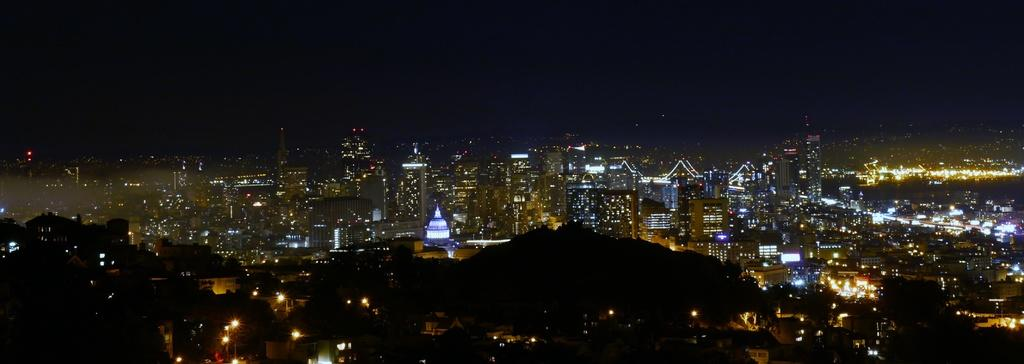What type of structures are visible in the image? A: There are buildings in the image. What else can be seen in the image besides the buildings? There are lights visible in the image. Can you describe the overall lighting in the image? The image appears to be slightly dark. What type of voyage is depicted in the image? There is no voyage depicted in the image; it features buildings and lights. What coastline can be seen in the image? There is no coastline present in the image; it features buildings and lights. 